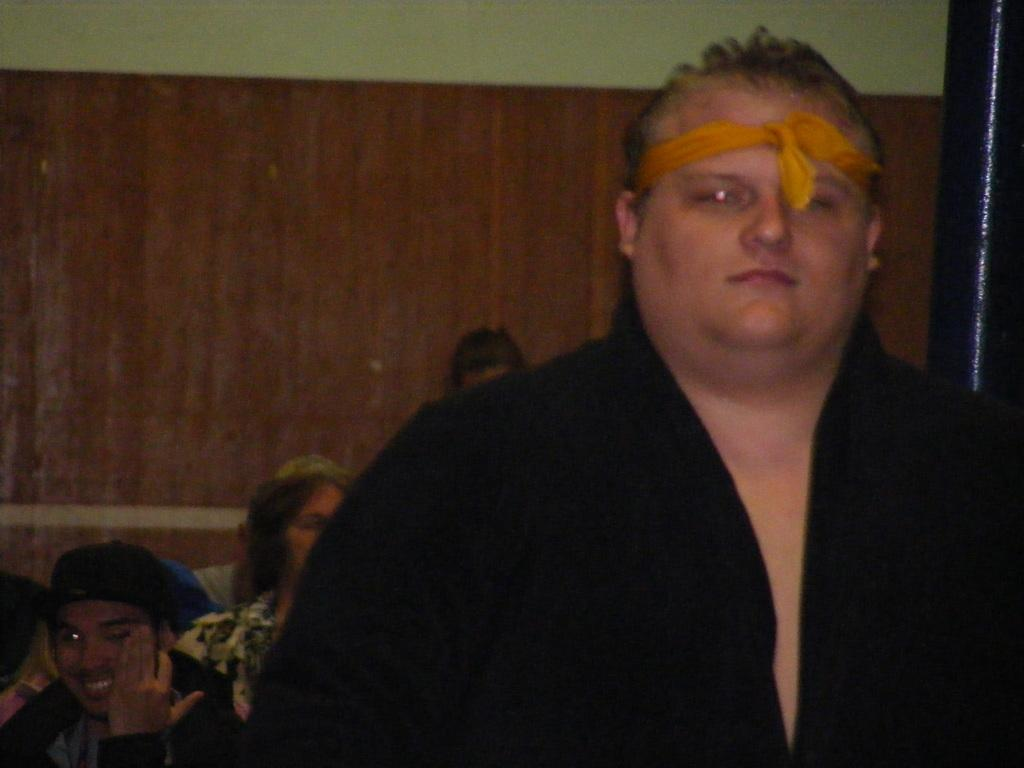Who is present in the image? There is a man in the image. What is the man doing in the image? The man has a cloth tied to his forehead. Are there any other people in the image? Yes, there are people in the image. What can be seen in the background of the image? There is a wall in the background of the image. What type of soda is the man drinking in the image? There is no soda present in the image; the man has a cloth tied to his forehead. What is the man using to plough the field in the image? There is no plough or field present in the image; the man is simply wearing a cloth tied to his forehead. 